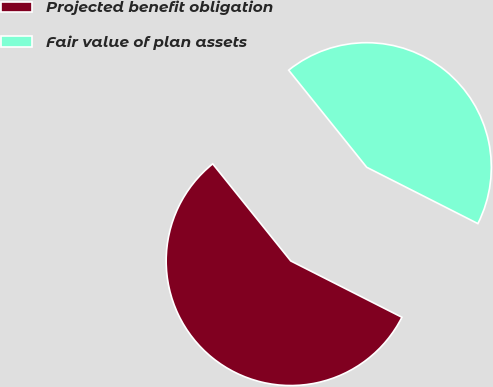Convert chart to OTSL. <chart><loc_0><loc_0><loc_500><loc_500><pie_chart><fcel>Projected benefit obligation<fcel>Fair value of plan assets<nl><fcel>56.76%<fcel>43.24%<nl></chart> 